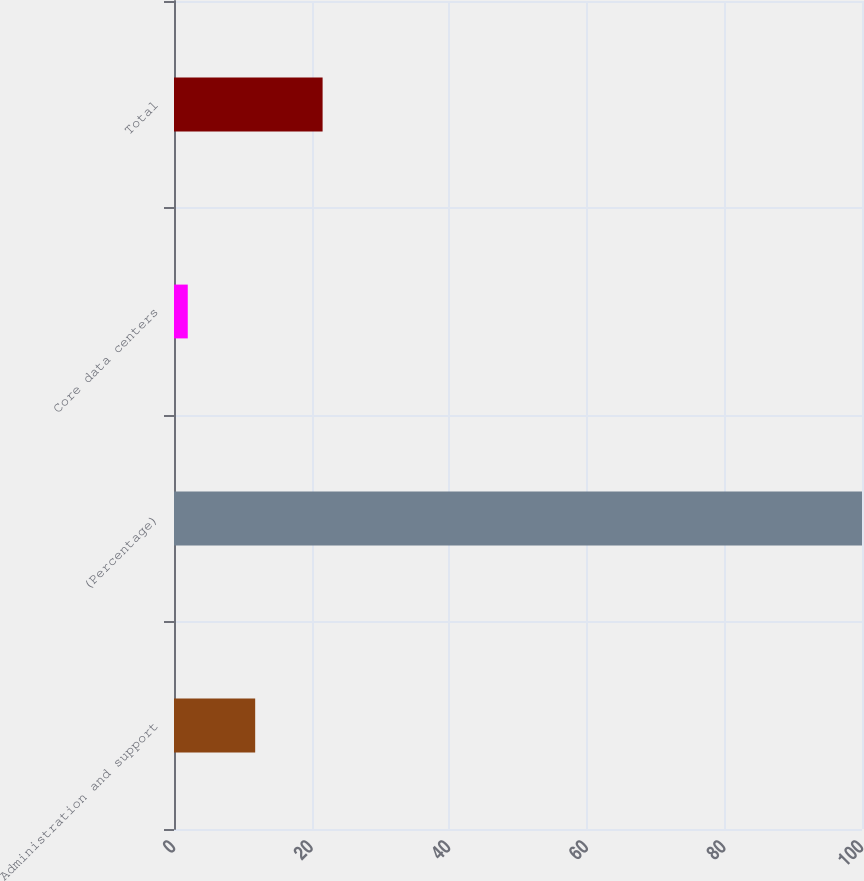<chart> <loc_0><loc_0><loc_500><loc_500><bar_chart><fcel>Administration and support<fcel>(Percentage)<fcel>Core data centers<fcel>Total<nl><fcel>11.8<fcel>100<fcel>2<fcel>21.6<nl></chart> 